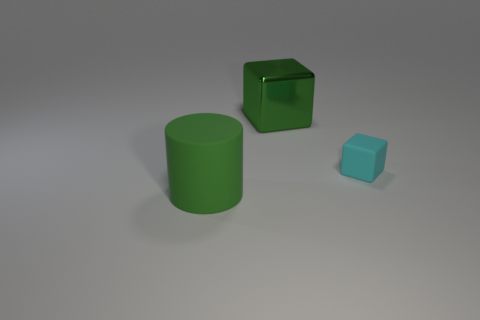Add 3 big brown metal cubes. How many objects exist? 6 Subtract all cylinders. How many objects are left? 2 Add 3 red metal objects. How many red metal objects exist? 3 Subtract 0 yellow spheres. How many objects are left? 3 Subtract all tiny cyan metal cylinders. Subtract all green cylinders. How many objects are left? 2 Add 3 green metallic things. How many green metallic things are left? 4 